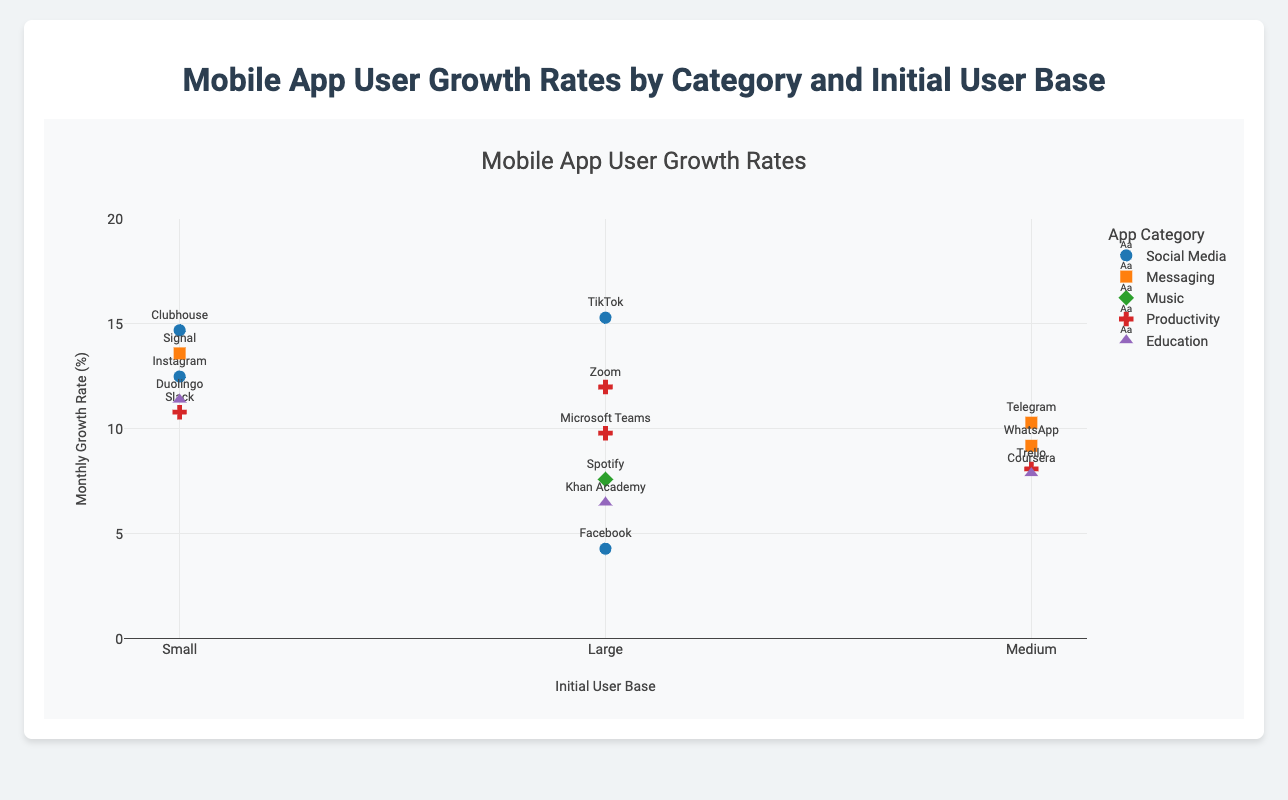What is the title of the figure? The title is displayed at the top of the figure and reads "Mobile App User Growth Rates by Category and Initial User Base"
Answer: Mobile App User Growth Rates by Category and Initial User Base Which app category has the color '#ff7f0e'? The colors are listed in the legend of the plot. The color '#ff7f0e' corresponds to the category "Messaging".
Answer: Messaging What is the shape of the markers used for the "Productivity" category? Each category has a distinct marker shape indicated by the legend. The "Productivity" category uses the square shape.
Answer: Square What is the average monthly growth rate of apps in the "Social Media" category? The "Social Media" category includes Instagram (12.5), TikTok (15.3), Clubhouse (14.7), and Facebook (4.3). Adding these values gives 46.8, divided by 4 yields an average of 11.7.
Answer: 11.7 What is the total number of apps categorized under "Education"? The "Education" category includes Duolingo, Coursera, and Khan Academy. Counting these apps gives a total of 3.
Answer: 3 Which has a higher monthly growth rate: Instagram or TikTok? The plot shows that Instagram has a growth rate of 12.5, while TikTok has 15.3. Since 15.3 is greater than 12.5, TikTok has a higher growth rate.
Answer: TikTok Is the monthly growth rate of Slack greater than the monthly growth rate of Microsoft Teams? According to the figure, Slack has a growth rate of 10.8, while Microsoft Teams has 9.8. Since 10.8 is greater than 9.8, Slack's growth rate is higher.
Answer: Yes Which app in the "Messaging" category has the highest monthly growth rate? The "Messaging" category includes WhatsApp (9.2), Signal (13.6), and Telegram (10.3). The highest among these is Signal at 13.6.
Answer: Signal What is the initial user base size of the app with the highest monthly growth rate? Observing the plot, TikTok has the highest monthly growth rate (15.3) and is in the "Large" initial user base category.
Answer: Large How many apps have a monthly growth rate higher than 10%? Inspecting the figure, the apps with growth rates higher than 10% are Instagram, TikTok, Slack, Clubhouse, Duolingo, Signal, and Telegram. There are 7 apps in total.
Answer: 7 